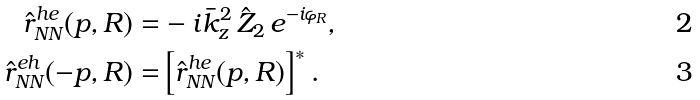<formula> <loc_0><loc_0><loc_500><loc_500>\hat { r } _ { N N } ^ { h e } ( p , R ) = & - i \bar { k } _ { z } ^ { 2 } \, \hat { Z } _ { 2 } \, e ^ { - i \varphi _ { R } } , \\ \hat { r } _ { N N } ^ { e h } ( - p , R ) = & \left [ \hat { r } _ { N N } ^ { h e } ( p , R ) \right ] ^ { \ast } .</formula> 